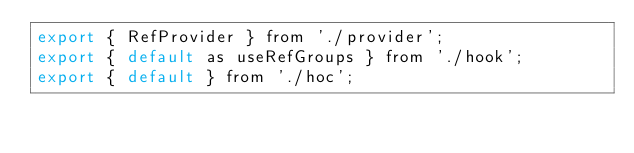Convert code to text. <code><loc_0><loc_0><loc_500><loc_500><_JavaScript_>export { RefProvider } from './provider';
export { default as useRefGroups } from './hook';
export { default } from './hoc';
</code> 